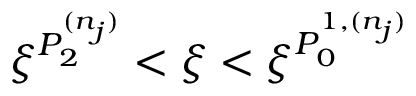Convert formula to latex. <formula><loc_0><loc_0><loc_500><loc_500>\xi ^ { P _ { 2 } ^ { ( n _ { j } ) } } < \xi < \xi ^ { P _ { 0 } ^ { 1 , ( n _ { j } ) } }</formula> 